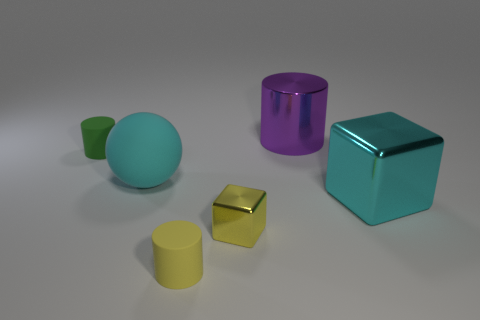How big is the cylinder that is behind the small matte cylinder behind the yellow metal object?
Make the answer very short. Large. The green rubber thing has what size?
Provide a short and direct response. Small. There is a small thing that is to the left of the tiny yellow metallic thing and in front of the big cyan shiny object; what shape is it?
Offer a terse response. Cylinder. There is a big metal thing that is the same shape as the tiny yellow metal object; what is its color?
Your answer should be compact. Cyan. What number of objects are either tiny yellow objects in front of the large purple thing or objects behind the big cyan shiny block?
Provide a succinct answer. 5. The big cyan matte object has what shape?
Ensure brevity in your answer.  Sphere. There is a large object that is the same color as the matte ball; what shape is it?
Offer a terse response. Cube. How many small cylinders have the same material as the sphere?
Offer a terse response. 2. What is the color of the tiny block?
Provide a short and direct response. Yellow. What is the color of the metal block that is the same size as the yellow rubber cylinder?
Your answer should be very brief. Yellow. 